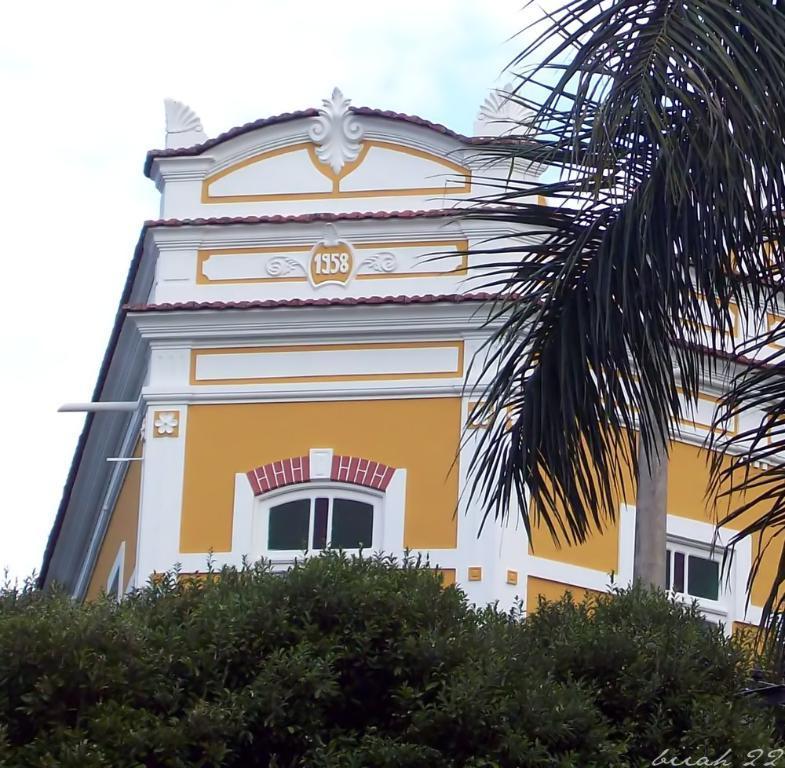How would you summarize this image in a sentence or two? In this image we can see a house, windows, there are trees, plants, also we can see the sky, and some text on the image. 